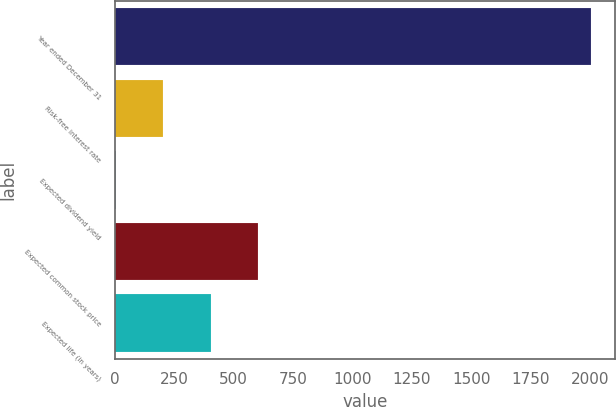Convert chart to OTSL. <chart><loc_0><loc_0><loc_500><loc_500><bar_chart><fcel>Year ended December 31<fcel>Risk-free interest rate<fcel>Expected dividend yield<fcel>Expected common stock price<fcel>Expected life (in years)<nl><fcel>2005<fcel>203.91<fcel>3.79<fcel>604.15<fcel>404.03<nl></chart> 